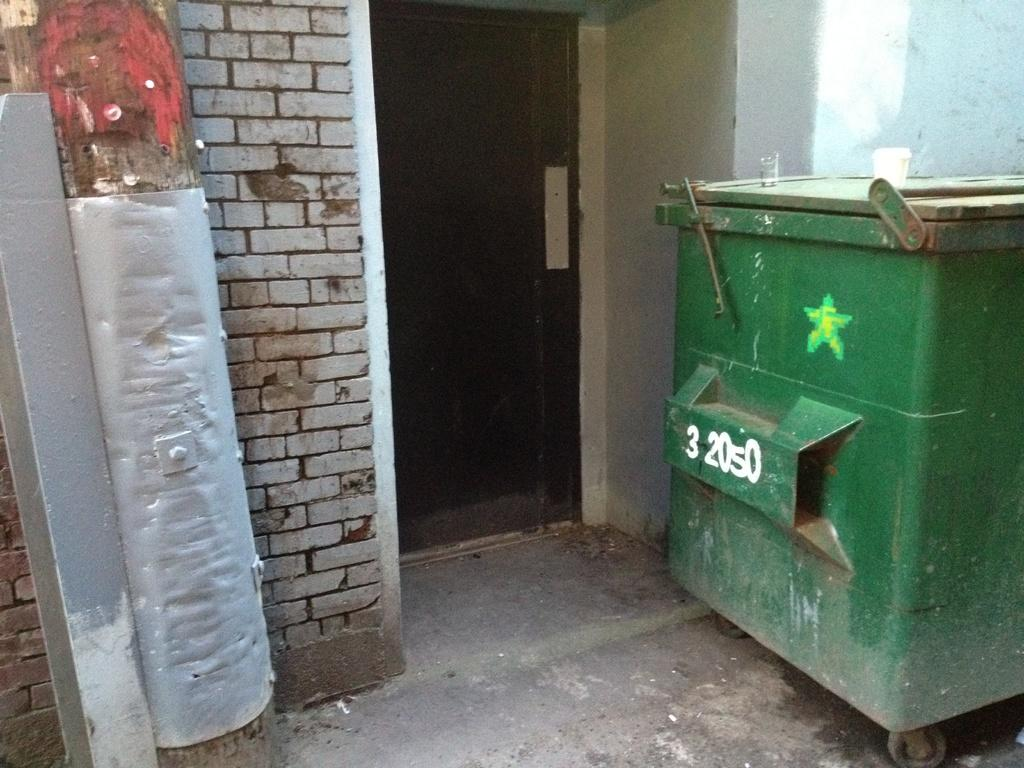<image>
Render a clear and concise summary of the photo. Green garbage can outside with the numbers 32050 on it. 